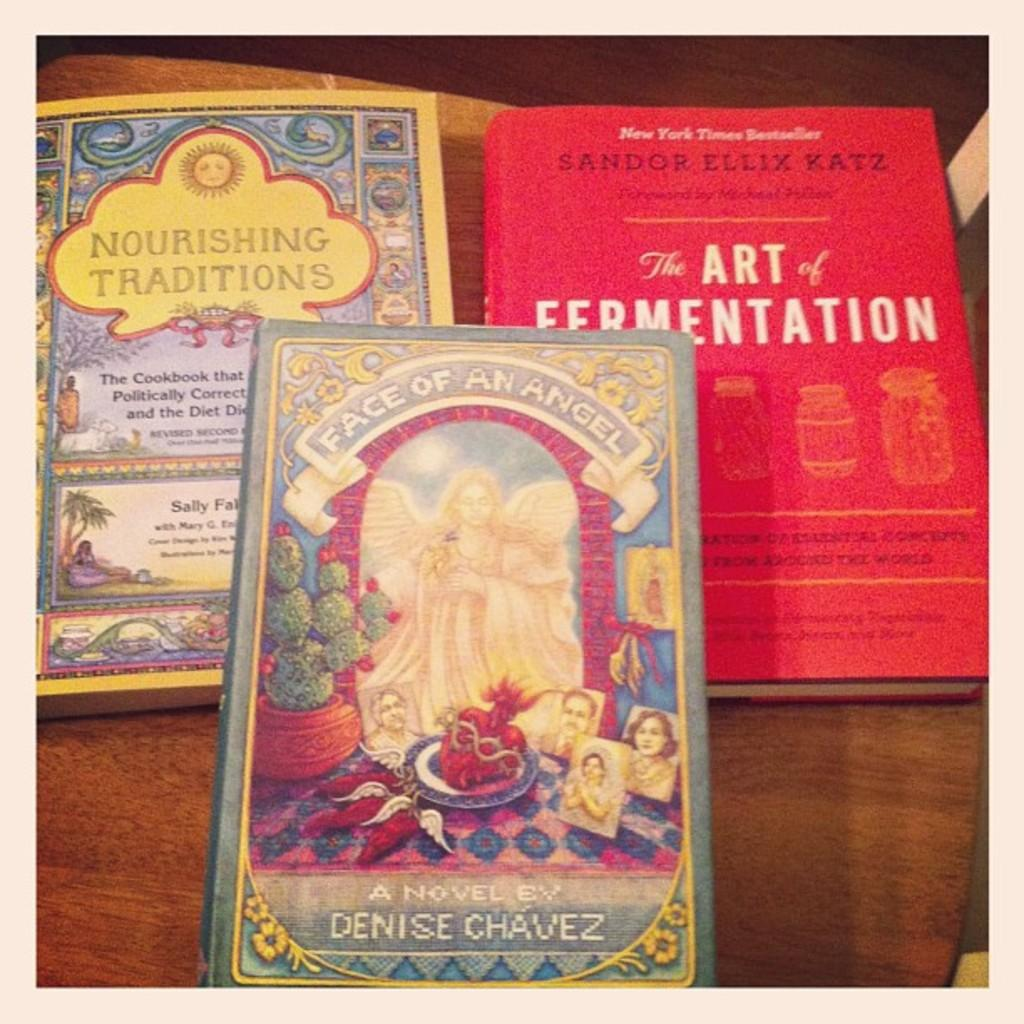<image>
Create a compact narrative representing the image presented. Three books, including Face of an Angel by Denise Chavez. 